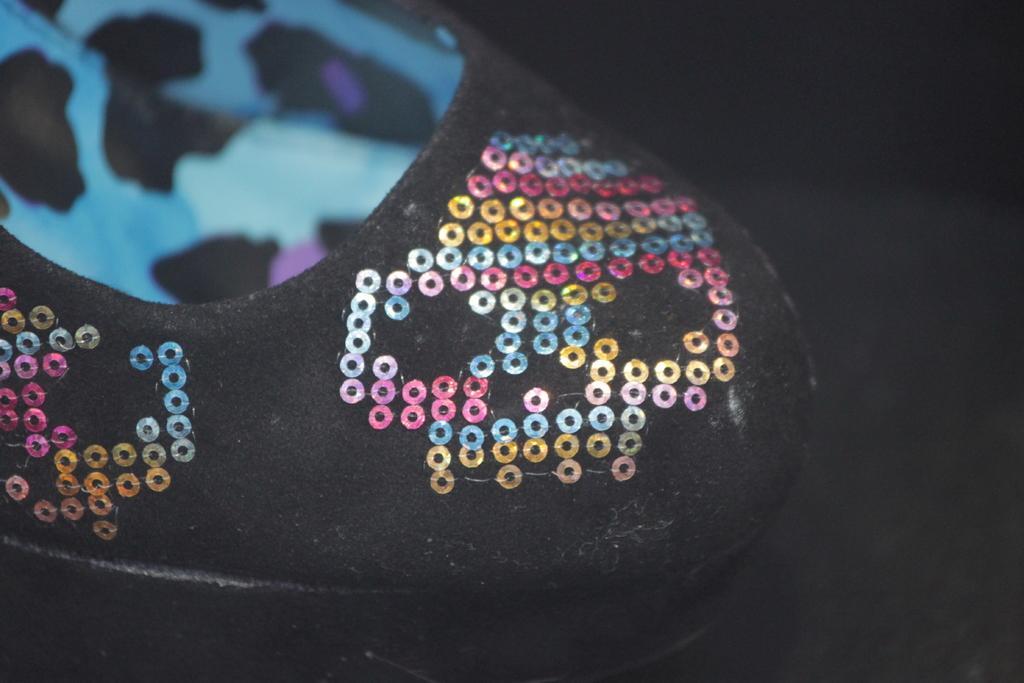Please provide a concise description of this image. In this image there is a shoe, in the background it is dark. 